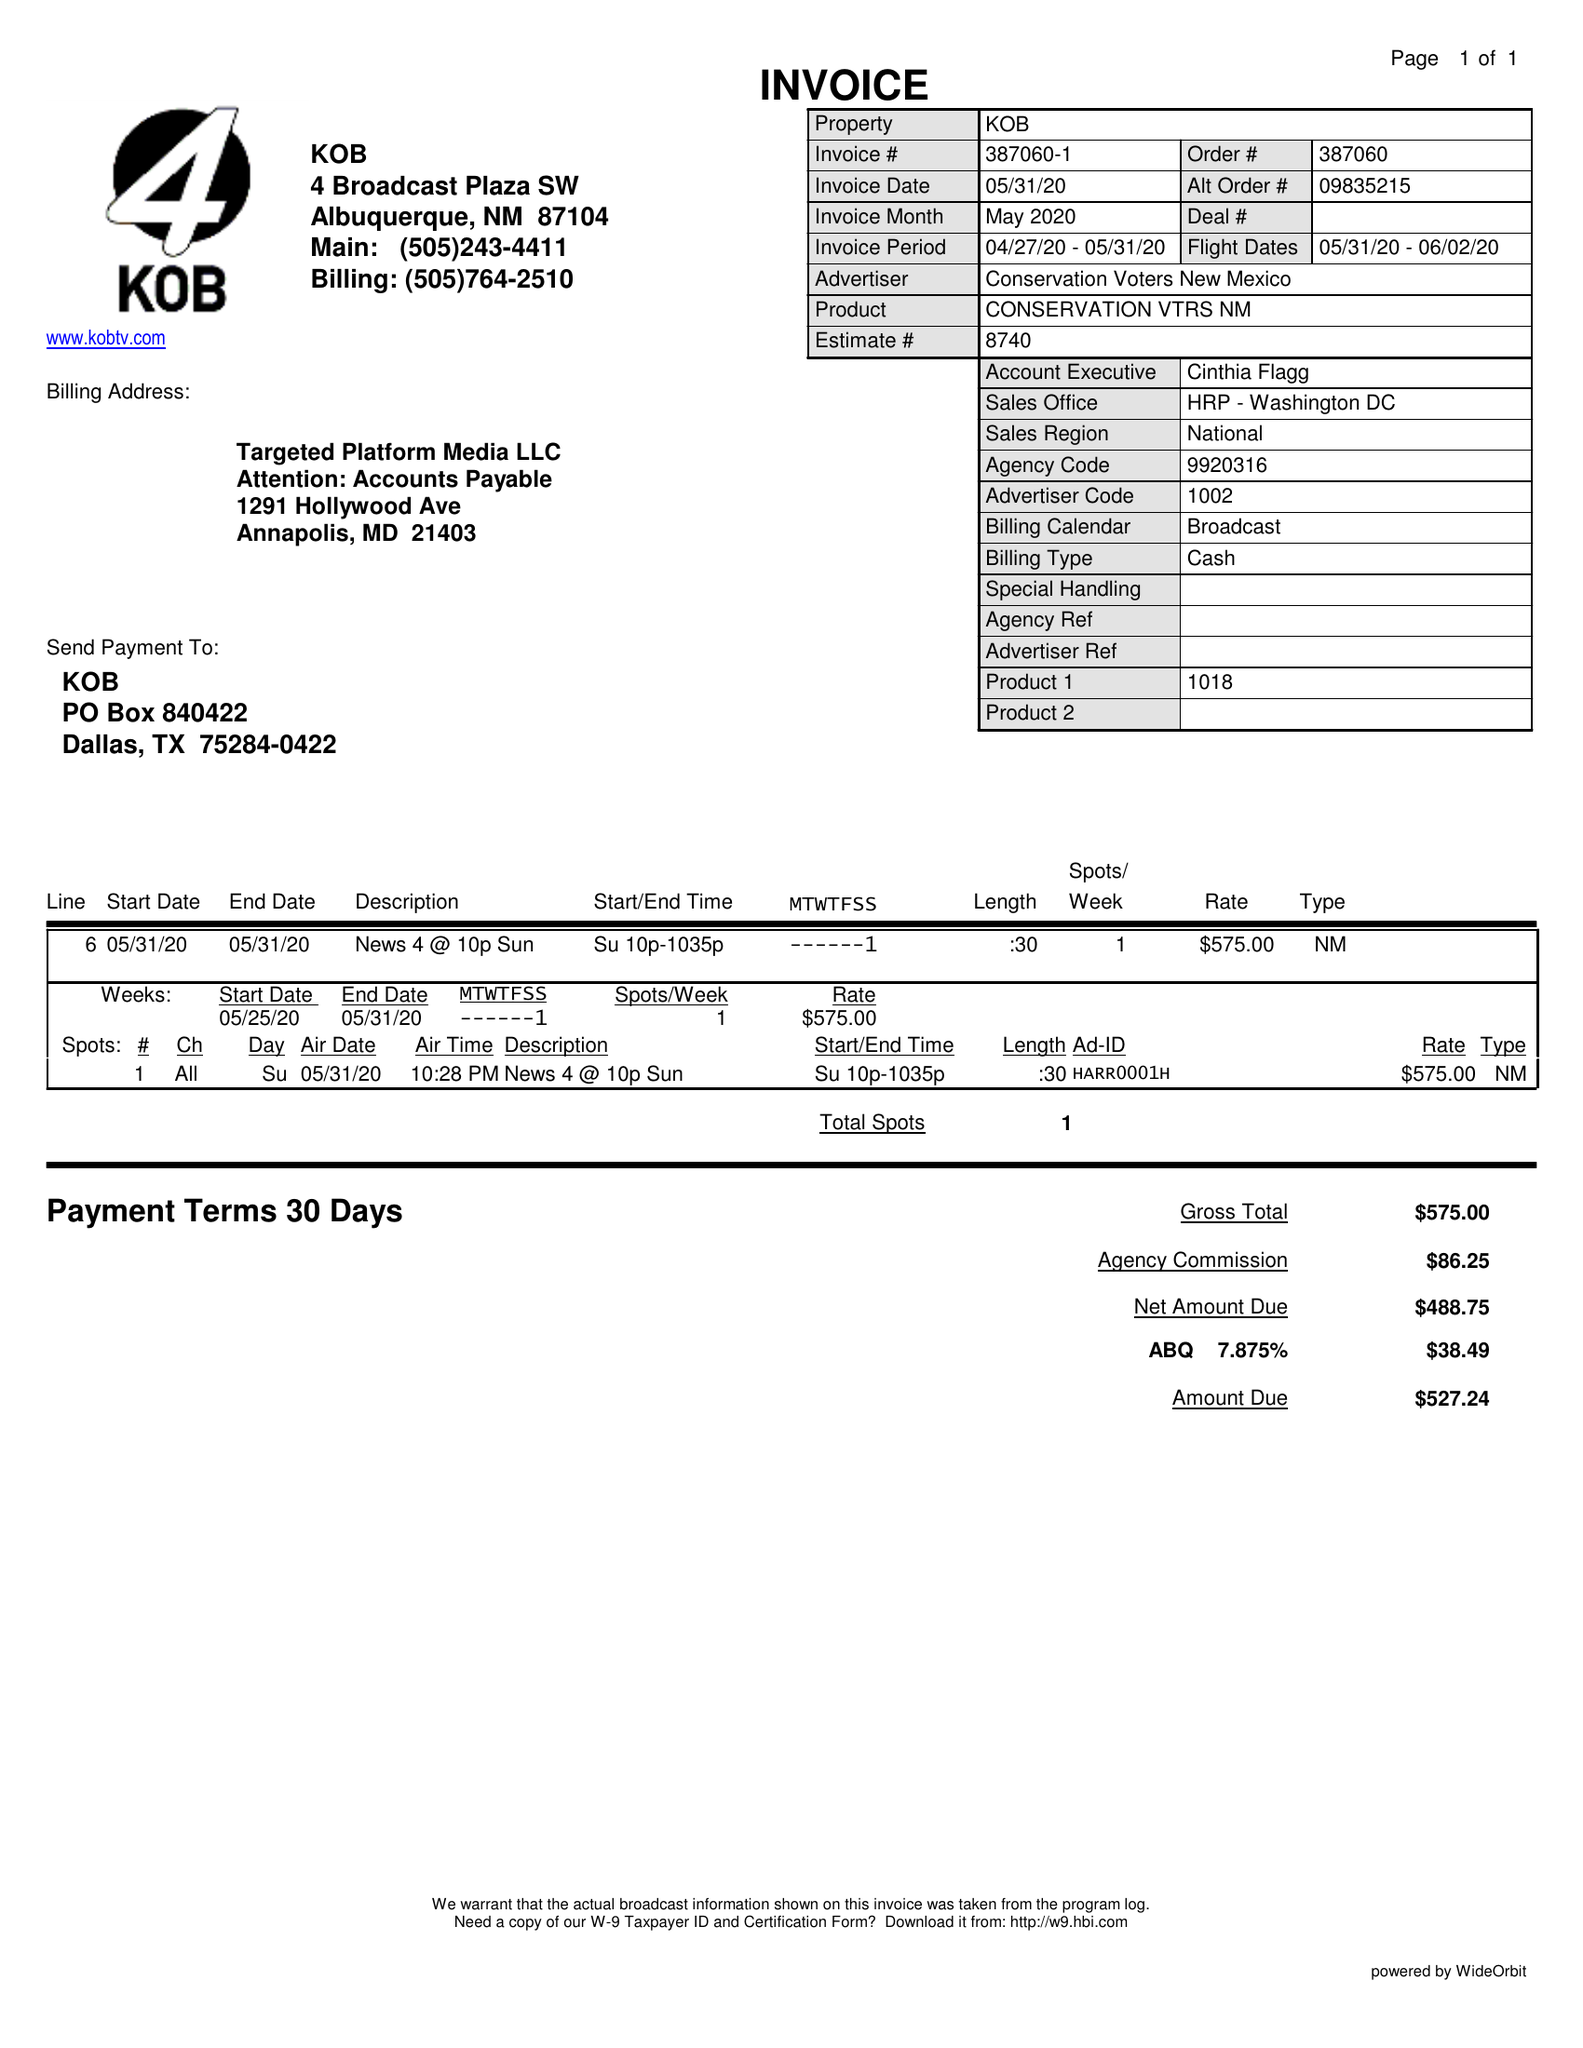What is the value for the flight_to?
Answer the question using a single word or phrase. 06/02/20 